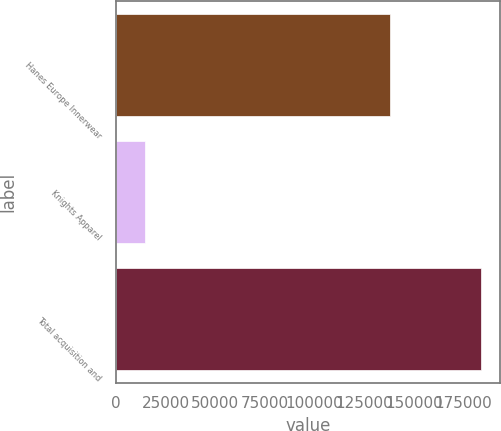Convert chart. <chart><loc_0><loc_0><loc_500><loc_500><bar_chart><fcel>Hanes Europe Innerwear<fcel>Knights Apparel<fcel>Total acquisition and<nl><fcel>138116<fcel>14789<fcel>184019<nl></chart> 